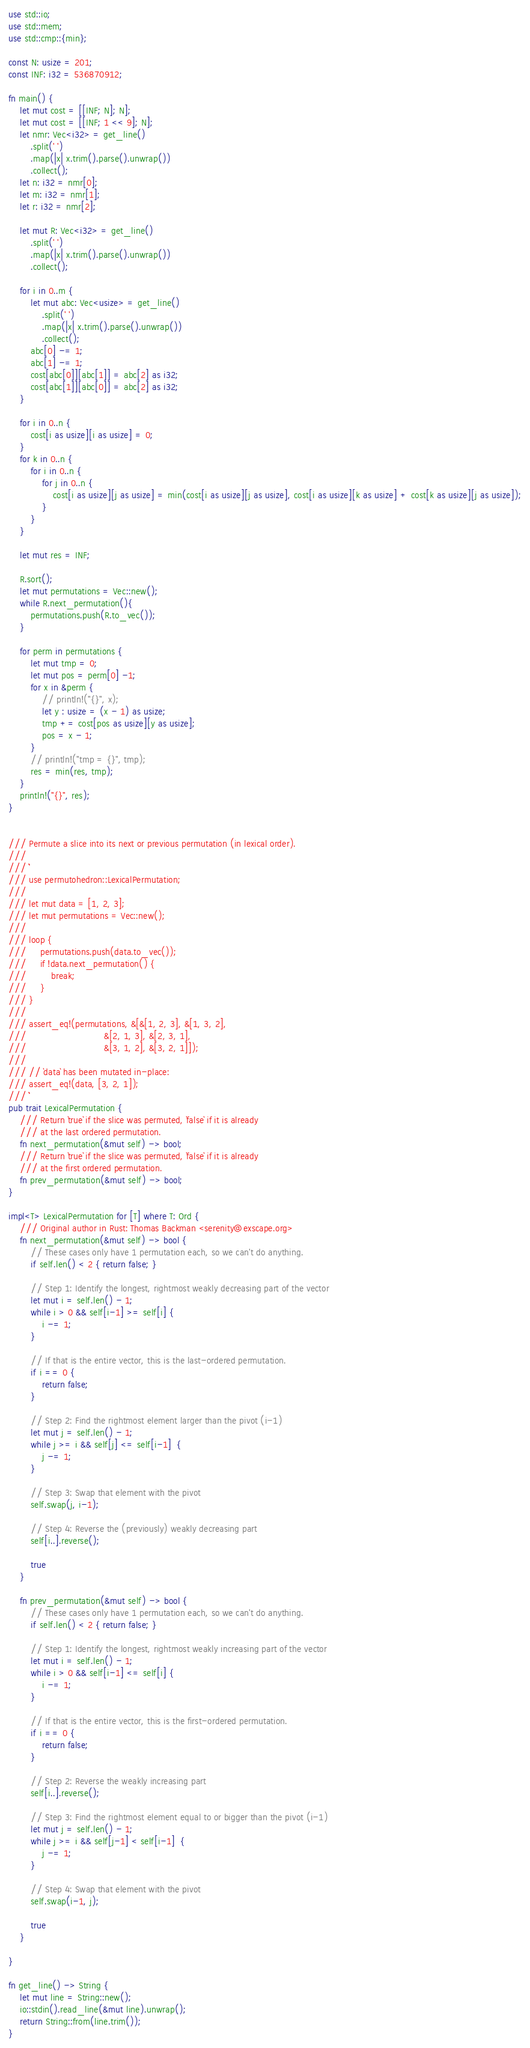<code> <loc_0><loc_0><loc_500><loc_500><_Rust_>use std::io;
use std::mem;
use std::cmp::{min};

const N: usize = 201;
const INF: i32 = 536870912;

fn main() {
    let mut cost = [[INF; N]; N];
    let mut cost = [[INF; 1 << 9]; N];
    let nmr: Vec<i32> = get_line()
        .split(' ')
        .map(|x| x.trim().parse().unwrap())
        .collect();
    let n: i32 = nmr[0];
    let m: i32 = nmr[1];
    let r: i32 = nmr[2];

    let mut R: Vec<i32> = get_line()
        .split(' ')
        .map(|x| x.trim().parse().unwrap())
        .collect();

    for i in 0..m {
        let mut abc: Vec<usize> = get_line()
            .split(' ')
            .map(|x| x.trim().parse().unwrap())
            .collect();
        abc[0] -= 1;
        abc[1] -= 1;
        cost[abc[0]][abc[1]] = abc[2] as i32;
        cost[abc[1]][abc[0]] = abc[2] as i32;
    }

    for i in 0..n {
        cost[i as usize][i as usize] = 0;
    }
    for k in 0..n {
        for i in 0..n {
            for j in 0..n {
                cost[i as usize][j as usize] = min(cost[i as usize][j as usize], cost[i as usize][k as usize] + cost[k as usize][j as usize]);
            }
        }
    }

    let mut res = INF;

    R.sort();
    let mut permutations = Vec::new();
    while R.next_permutation(){
        permutations.push(R.to_vec());
    }

    for perm in permutations {
        let mut tmp = 0;
        let mut pos = perm[0] -1;
        for x in &perm {
            // println!("{}", x);
            let y : usize = (x - 1) as usize;
            tmp += cost[pos as usize][y as usize];
            pos = x - 1;
        }
        // println!("tmp = {}", tmp);
        res = min(res, tmp);
    }
    println!("{}", res);
}


/// Permute a slice into its next or previous permutation (in lexical order).
///
/// ```
/// use permutohedron::LexicalPermutation;
///
/// let mut data = [1, 2, 3];
/// let mut permutations = Vec::new();
///
/// loop {
///     permutations.push(data.to_vec());
///     if !data.next_permutation() {
///         break;
///     }
/// }
///
/// assert_eq!(permutations, &[&[1, 2, 3], &[1, 3, 2],
///                            &[2, 1, 3], &[2, 3, 1],
///                            &[3, 1, 2], &[3, 2, 1]]);
///
/// // `data` has been mutated in-place:
/// assert_eq!(data, [3, 2, 1]);
/// ```
pub trait LexicalPermutation {
    /// Return `true` if the slice was permuted, `false` if it is already
    /// at the last ordered permutation.
    fn next_permutation(&mut self) -> bool;
    /// Return `true` if the slice was permuted, `false` if it is already
    /// at the first ordered permutation.
    fn prev_permutation(&mut self) -> bool;
}

impl<T> LexicalPermutation for [T] where T: Ord {
    /// Original author in Rust: Thomas Backman <serenity@exscape.org>
    fn next_permutation(&mut self) -> bool {
        // These cases only have 1 permutation each, so we can't do anything.
        if self.len() < 2 { return false; }

        // Step 1: Identify the longest, rightmost weakly decreasing part of the vector
        let mut i = self.len() - 1;
        while i > 0 && self[i-1] >= self[i] {
            i -= 1;
        }

        // If that is the entire vector, this is the last-ordered permutation.
        if i == 0 {
            return false;
        }

        // Step 2: Find the rightmost element larger than the pivot (i-1)
        let mut j = self.len() - 1;
        while j >= i && self[j] <= self[i-1]  {
            j -= 1;
        }

        // Step 3: Swap that element with the pivot
        self.swap(j, i-1);

        // Step 4: Reverse the (previously) weakly decreasing part
        self[i..].reverse();

        true
    }

    fn prev_permutation(&mut self) -> bool {
        // These cases only have 1 permutation each, so we can't do anything.
        if self.len() < 2 { return false; }

        // Step 1: Identify the longest, rightmost weakly increasing part of the vector
        let mut i = self.len() - 1;
        while i > 0 && self[i-1] <= self[i] {
            i -= 1;
        }

        // If that is the entire vector, this is the first-ordered permutation.
        if i == 0 {
            return false;
        }

        // Step 2: Reverse the weakly increasing part
        self[i..].reverse();

        // Step 3: Find the rightmost element equal to or bigger than the pivot (i-1)
        let mut j = self.len() - 1;
        while j >= i && self[j-1] < self[i-1]  {
            j -= 1;
        }

        // Step 4: Swap that element with the pivot
        self.swap(i-1, j);

        true
    }

}

fn get_line() -> String {
    let mut line = String::new();
    io::stdin().read_line(&mut line).unwrap();
    return String::from(line.trim());
}
</code> 